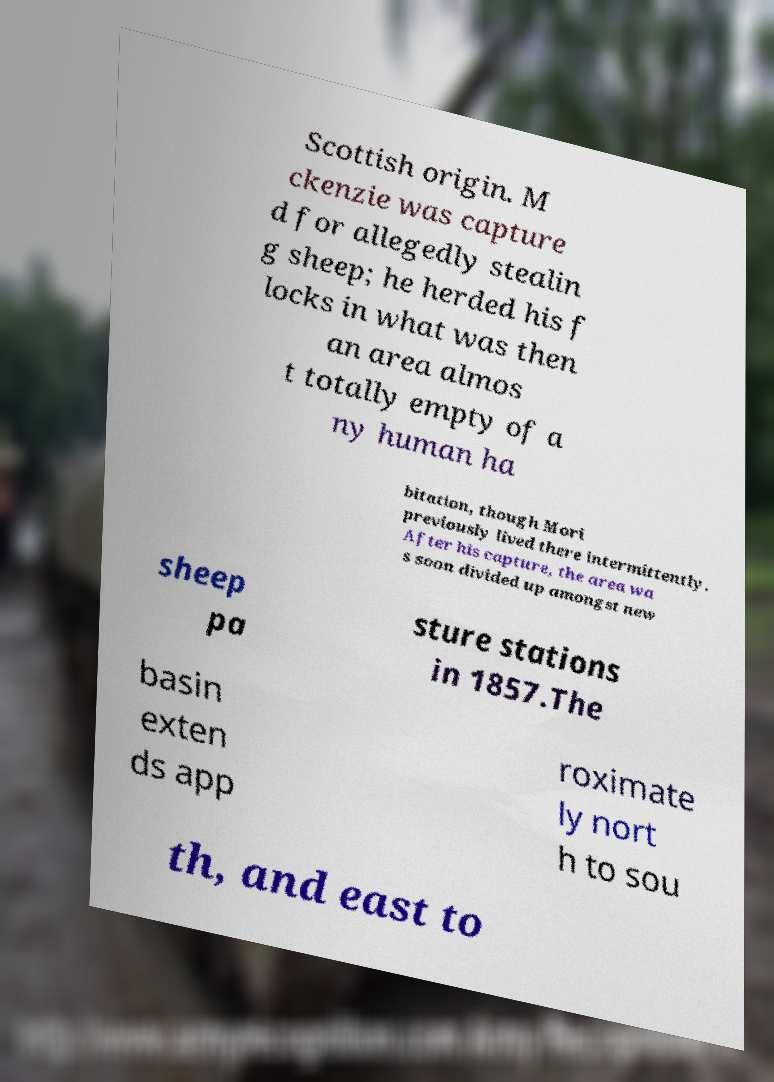Please identify and transcribe the text found in this image. Scottish origin. M ckenzie was capture d for allegedly stealin g sheep; he herded his f locks in what was then an area almos t totally empty of a ny human ha bitation, though Mori previously lived there intermittently. After his capture, the area wa s soon divided up amongst new sheep pa sture stations in 1857.The basin exten ds app roximate ly nort h to sou th, and east to 